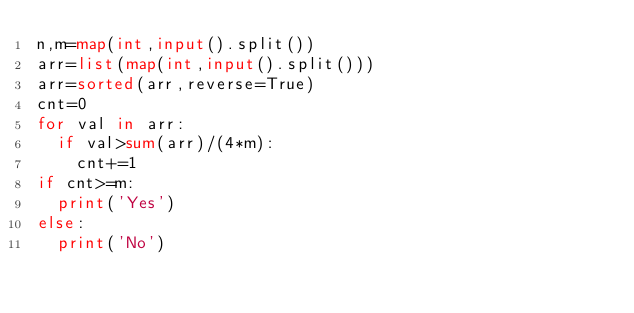Convert code to text. <code><loc_0><loc_0><loc_500><loc_500><_Python_>n,m=map(int,input().split())
arr=list(map(int,input().split()))
arr=sorted(arr,reverse=True)
cnt=0
for val in arr:
  if val>sum(arr)/(4*m):
    cnt+=1
if cnt>=m:
  print('Yes')
else:
  print('No')</code> 